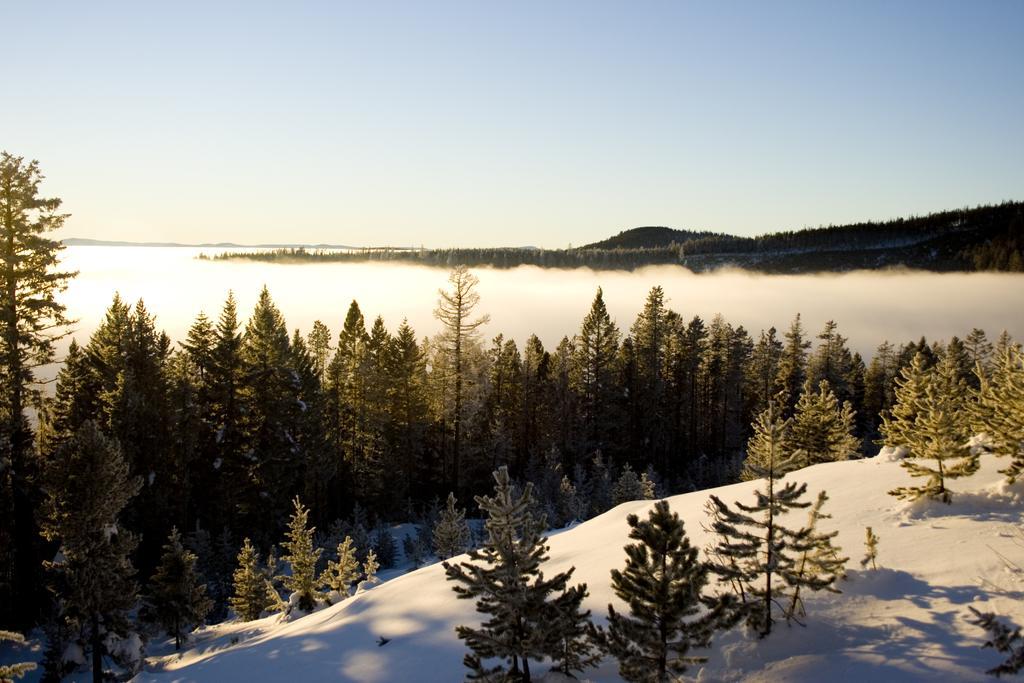How would you summarize this image in a sentence or two? In this image there are trees, in the background there is a river and mountains. 